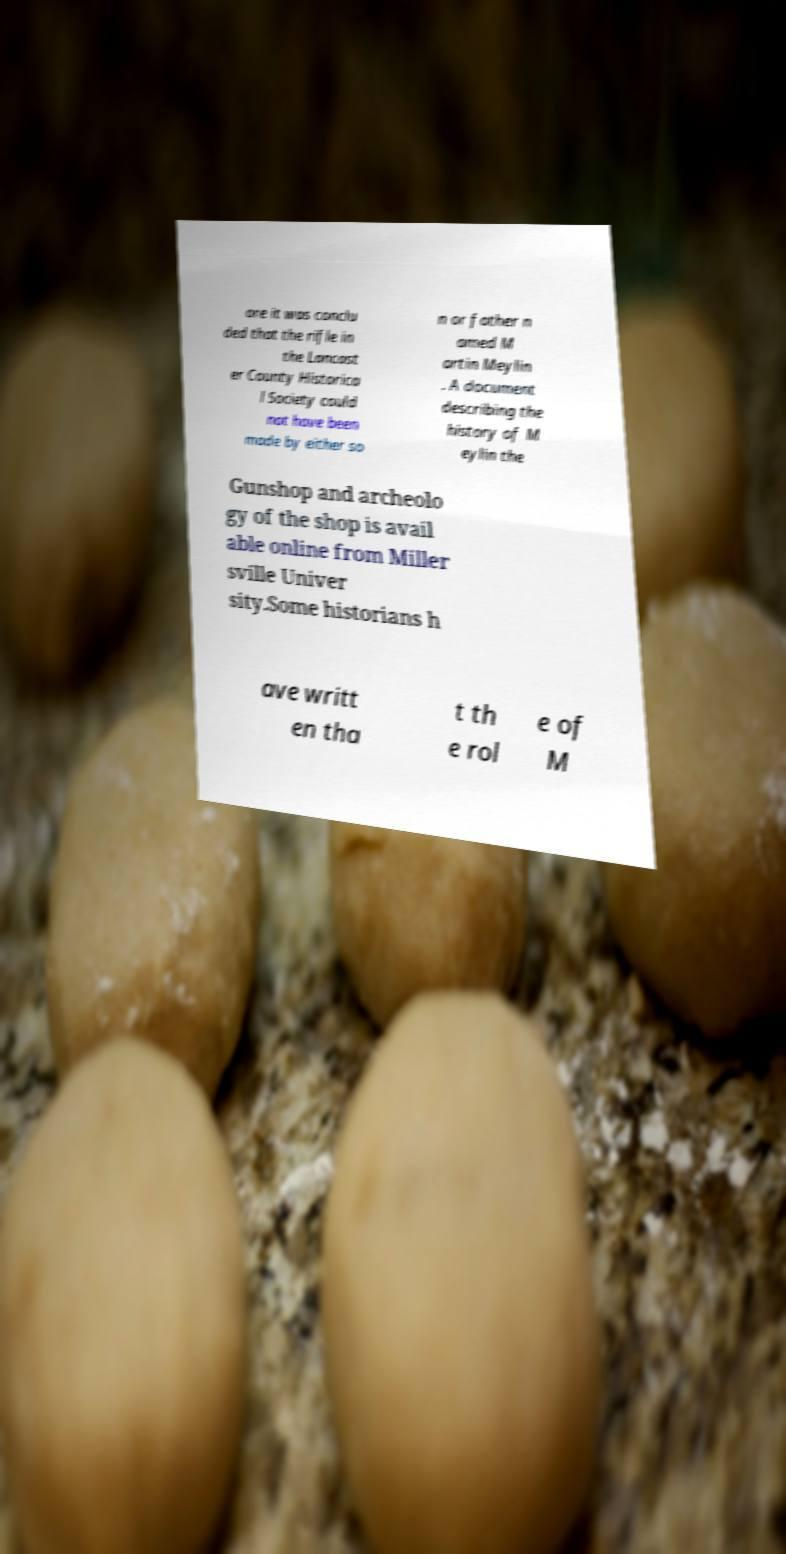Please read and relay the text visible in this image. What does it say? ore it was conclu ded that the rifle in the Lancast er County Historica l Society could not have been made by either so n or father n amed M artin Meylin . A document describing the history of M eylin the Gunshop and archeolo gy of the shop is avail able online from Miller sville Univer sity.Some historians h ave writt en tha t th e rol e of M 